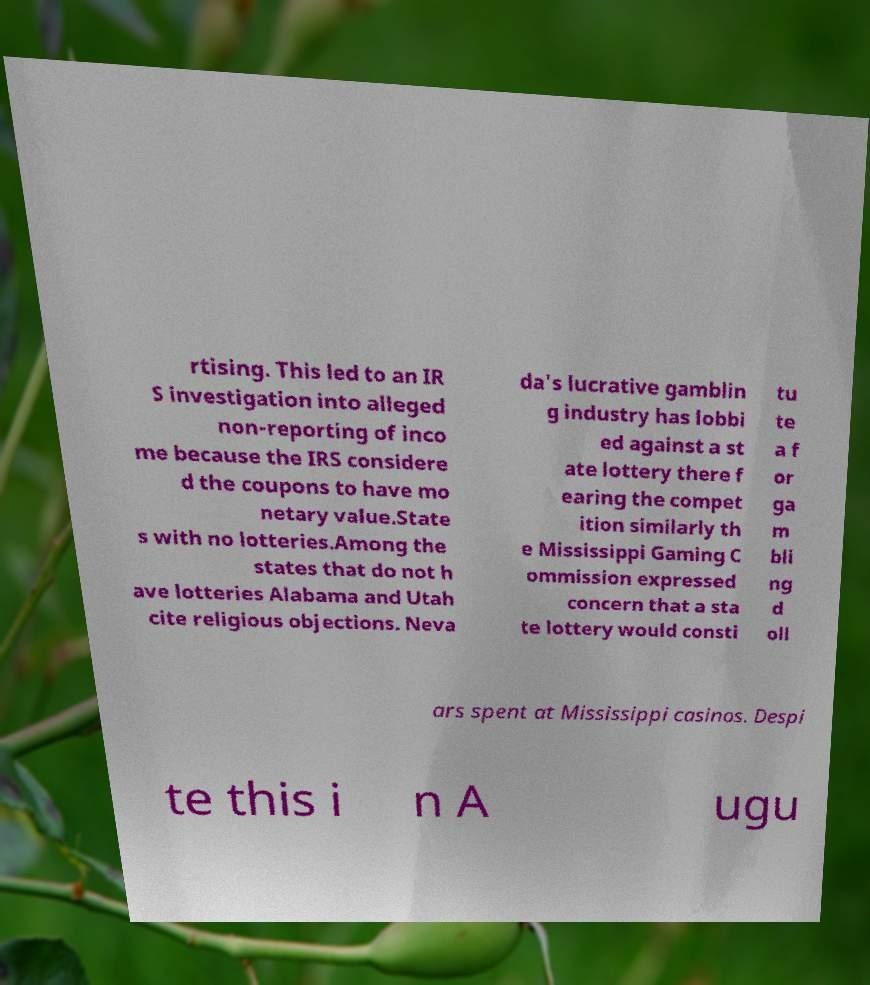Could you extract and type out the text from this image? rtising. This led to an IR S investigation into alleged non-reporting of inco me because the IRS considere d the coupons to have mo netary value.State s with no lotteries.Among the states that do not h ave lotteries Alabama and Utah cite religious objections. Neva da's lucrative gamblin g industry has lobbi ed against a st ate lottery there f earing the compet ition similarly th e Mississippi Gaming C ommission expressed concern that a sta te lottery would consti tu te a f or ga m bli ng d oll ars spent at Mississippi casinos. Despi te this i n A ugu 